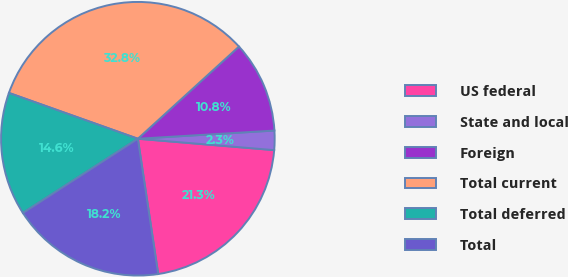Convert chart to OTSL. <chart><loc_0><loc_0><loc_500><loc_500><pie_chart><fcel>US federal<fcel>State and local<fcel>Foreign<fcel>Total current<fcel>Total deferred<fcel>Total<nl><fcel>21.3%<fcel>2.28%<fcel>10.81%<fcel>32.8%<fcel>14.56%<fcel>18.25%<nl></chart> 